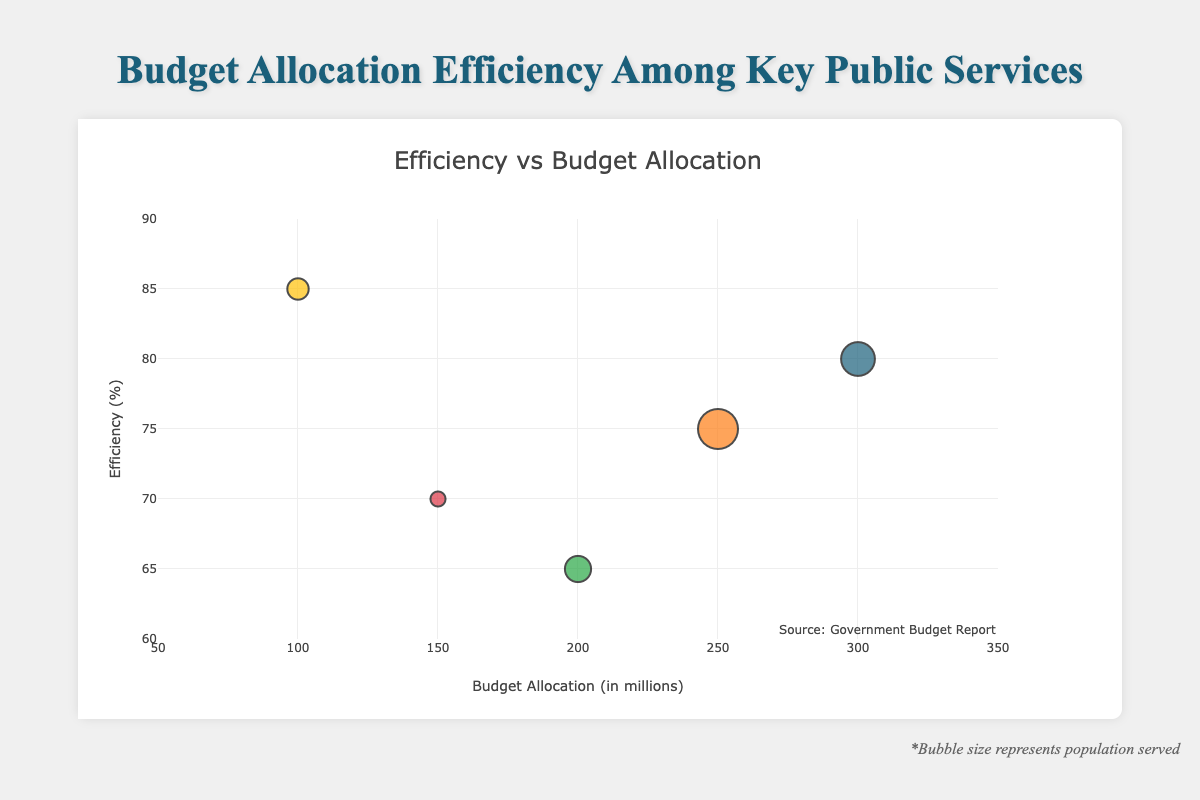What is the title of the chart? The title of the chart is displayed prominently at the top. It reads "Budget Allocation Efficiency Among Key Public Services".
Answer: Budget Allocation Efficiency Among Key Public Services How many services are represented in the chart? By counting the distinct bubble markers and their labels, we can see that there are five services represented in the chart.
Answer: Five What is the budget allocation for Education? Locate the bubble labeled "Education" and check the x-axis value it corresponds to. Education is positioned at 250 million on the x-axis.
Answer: 250 million Which service has the highest efficiency percentage? By looking at the y-axis and identifying the bubble that reaches the highest point, we see that "Social Services" has the highest efficiency at 85%.
Answer: Social Services What is the color of the bubble representing Public Safety? Identify the bubble labeled "Public Safety" and note its color. The Public Safety bubble is colored red.
Answer: Red Compare the budget allocations of Healthcare and Infrastructure. Which one is allocated more? By comparing the x-axis values for "Healthcare" and "Infrastructure", it's clear that Healthcare, with a budget allocation of 300 million, is allocated more than Infrastructure, which has 200 million.
Answer: Healthcare How much bigger is the population served by Healthcare compared to Public Safety? The population served by Healthcare is 5,000,000, while Public Safety serves 1,000,000. The difference is obtained by subtracting the smaller population from the larger one: 5,000,000 - 1,000,000 = 4,000,000.
Answer: 4,000,000 Which service serves the largest population? Determine the bubble with the largest size, corresponding to the highest population. The largest bubble represents "Education", serving 7,000,000 people.
Answer: Education Calculate the average efficiency of all the services. Add the efficiency percentages of all the services and divide by the number of services: (80 + 75 + 65 + 70 + 85) / 5 = 375 / 5 = 75%.
Answer: 75% Which service, despite having a low budget allocation, has a high efficiency score? Identify services with lower budget allocations on the x-axis but high efficiency on the y-axis. "Social Services" has a budget allocation of 100 million but an efficiency of 85%.
Answer: Social Services 